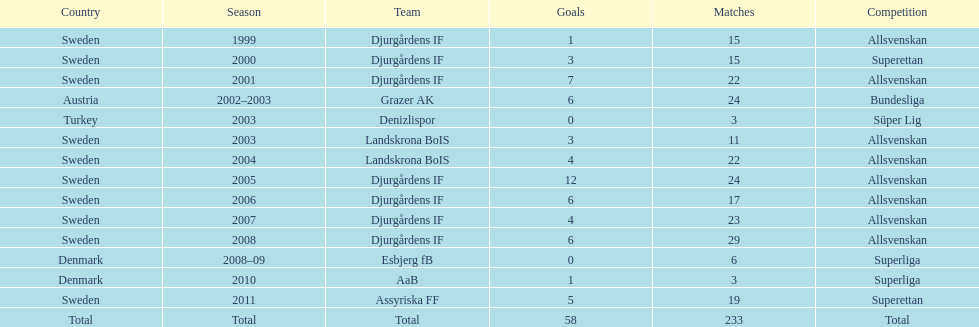How many matches did jones kusi-asare play in in his first season? 15. 